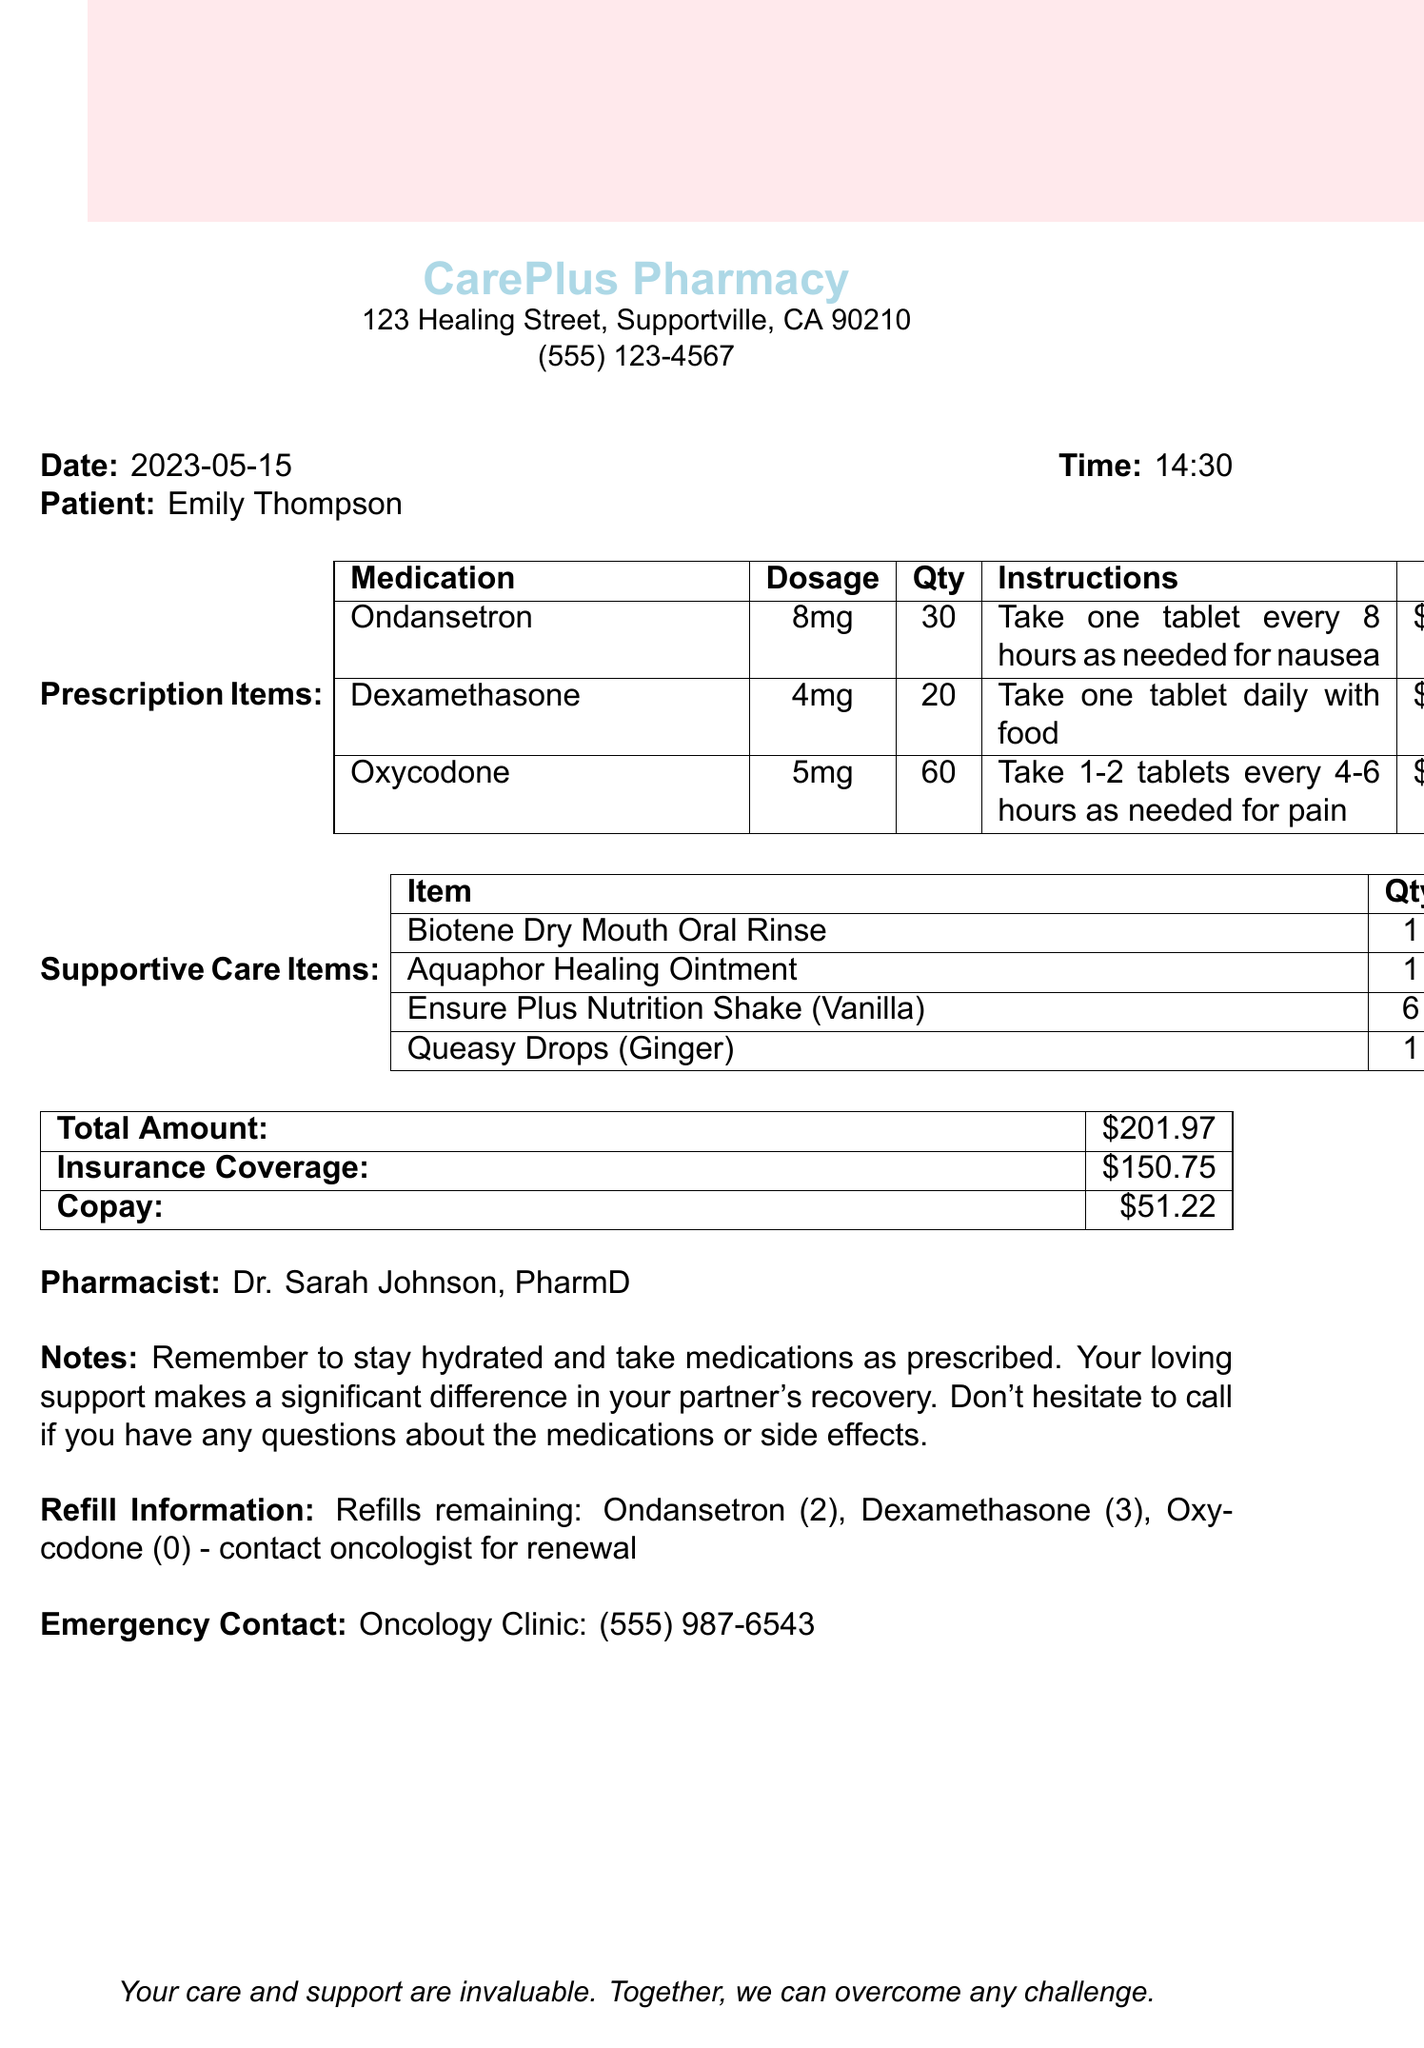What is the pharmacy name? The pharmacy name is listed at the top of the receipt.
Answer: CarePlus Pharmacy What is the date of the transaction? The date of the transaction is mentioned next to "Date:" on the receipt.
Answer: 2023-05-15 Who is the patient? The patient's name appears prominently on the receipt.
Answer: Emily Thompson What is the total amount? The total amount is summarized at the end of the document under "Total Amount:".
Answer: $201.97 What is the quantity of Oxycodone prescribed? The quantity of Oxycodone can be found in the table of prescription items.
Answer: 60 What are the refill details for Dexamethasone? The refill information for Dexamethasone is part of the refill details section in the document.
Answer: 3 How much is the copay? The copay amount is indicated in the financial summary section.
Answer: $51.22 What is one of the supportive care items listed? Supportive care items are listed under a specific section on the receipt.
Answer: Biotene Dry Mouth Oral Rinse What should you remember according to the notes? The notes at the bottom of the receipt provide guidance for the patient and caregiver.
Answer: Stay hydrated 